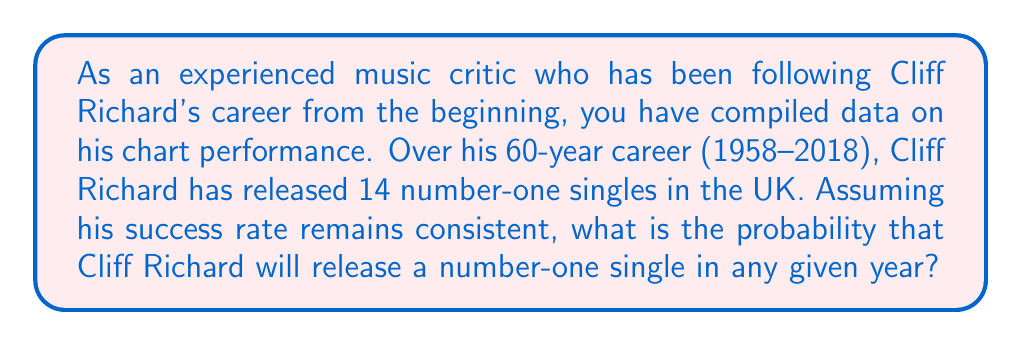Give your solution to this math problem. To solve this problem, we need to use the concept of probability based on historical data. We'll follow these steps:

1. Identify the total number of years in Cliff Richard's career:
   $\text{Total years} = 2018 - 1958 + 1 = 61$ years

2. Count the number of number-one singles:
   $\text{Number of number-one singles} = 14$

3. Calculate the probability using the formula:
   $$P(\text{number-one single in a year}) = \frac{\text{Number of favorable outcomes}}{\text{Total number of possible outcomes}}$$

   In this case:
   $$P(\text{number-one single in a year}) = \frac{\text{Number of number-one singles}}{\text{Total years}}$$

4. Substitute the values:
   $$P(\text{number-one single in a year}) = \frac{14}{61}$$

5. Simplify the fraction:
   $$P(\text{number-one single in a year}) = \frac{14}{61} \approx 0.2295$$

Therefore, based on historical data, the probability of Cliff Richard releasing a number-one single in any given year is approximately 0.2295 or 22.95%.
Answer: $\frac{14}{61} \approx 0.2295$ or 22.95% 